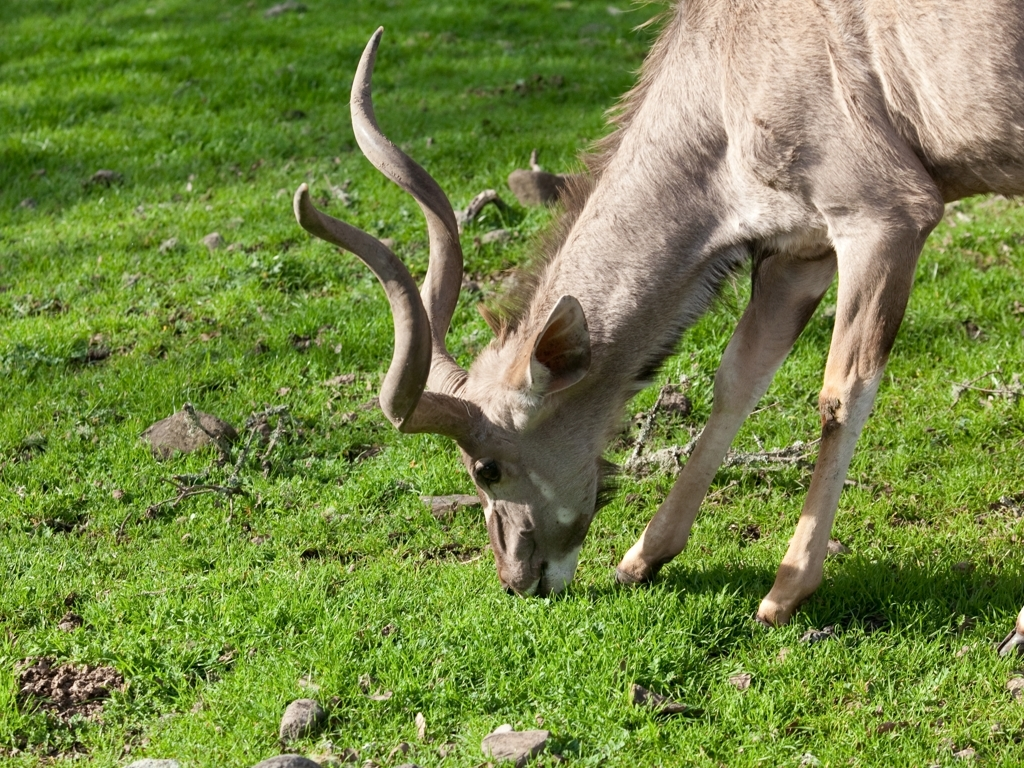Does the photo suffer from any noise or graininess? The photo appears to be clear with no significant noise or graininess affecting the quality. The details of the deer and the surrounding grass are sharp, suggesting that the image was taken in good light conditions and with a steady hand or camera support. 